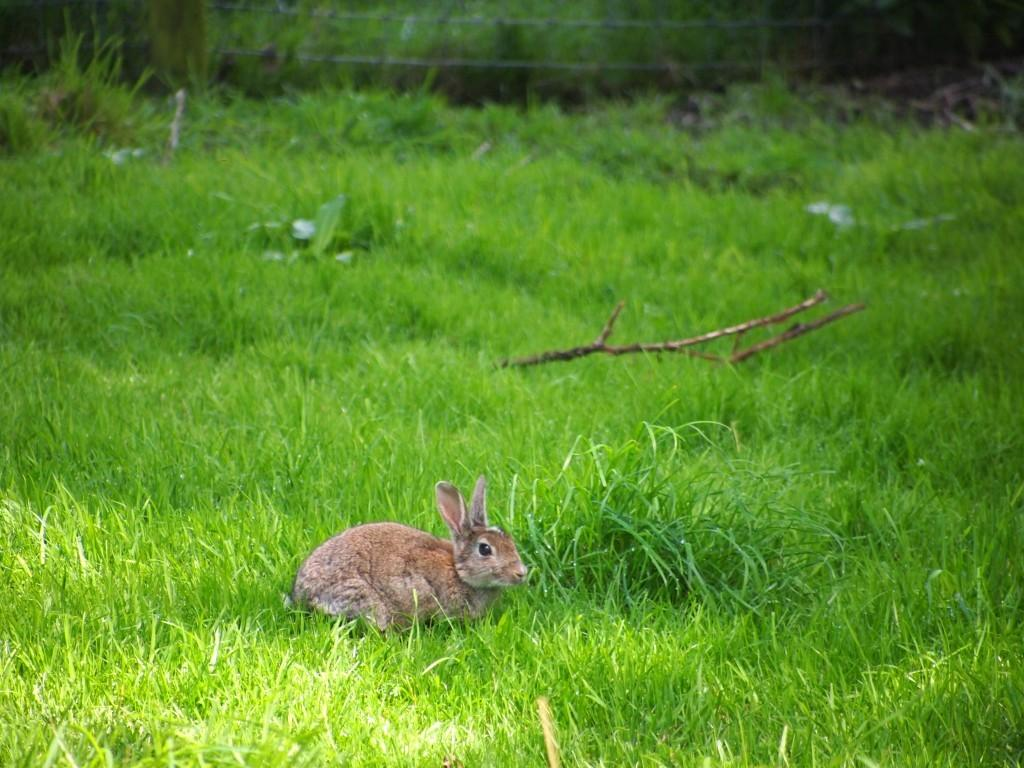Where was the image taken? The image was clicked outside. What is the main subject in the foreground of the image? There is a rabbit in the foreground of the image. What else can be seen in the image besides the rabbit? There are objects visible in the image. What type of vegetation is present in the image? There is green grass in the image. What type of mark can be seen on the rabbit's vest in the image? There is no vest or mark present on the rabbit in the image. 